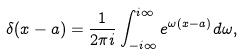Convert formula to latex. <formula><loc_0><loc_0><loc_500><loc_500>\delta ( x - a ) = \frac { 1 } { 2 \pi i } \int _ { - i \infty } ^ { i \infty } e ^ { \omega ( x - a ) } d \omega ,</formula> 